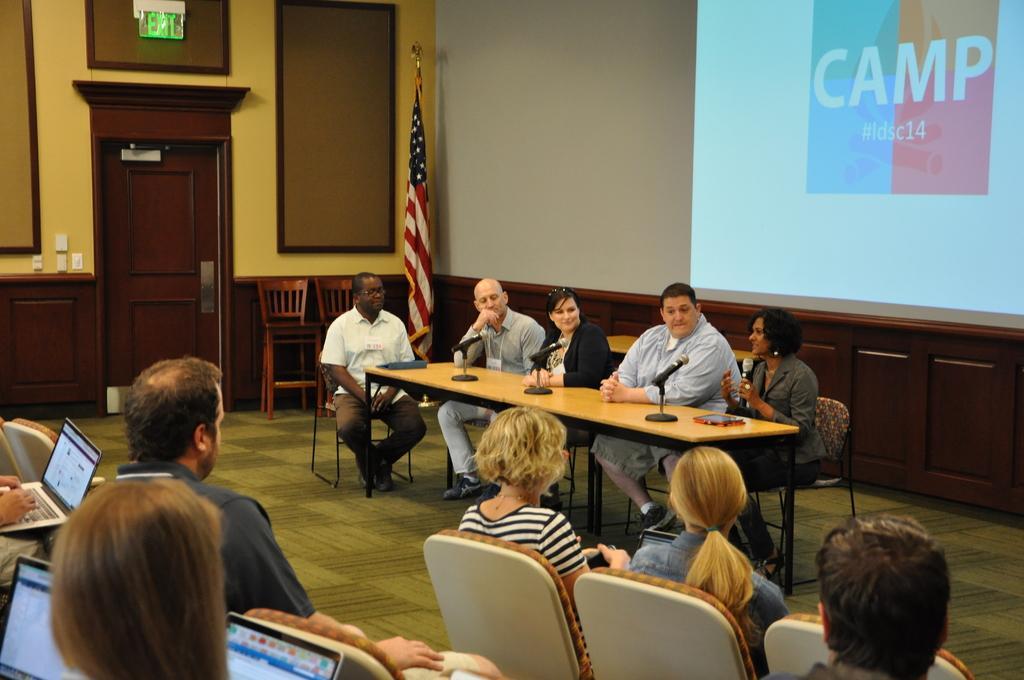Can you describe this image briefly? people are sitting on the chairs. at the left people are operating laptops. at the front of them there is a table on which microphones are present. people are sitting on the chairs and a person at the right is speaking while holding a microphone in her hand. behind them there is a flag and a screen on which camp is written. 